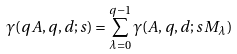<formula> <loc_0><loc_0><loc_500><loc_500>\gamma ( q A , q , d ; s ) = \sum _ { \lambda = 0 } ^ { q - 1 } \gamma ( A , q , d ; s M _ { \lambda } )</formula> 